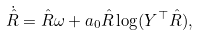Convert formula to latex. <formula><loc_0><loc_0><loc_500><loc_500>\dot { \hat { R } } & = \hat { R } \omega + a _ { 0 } \hat { R } \log ( Y ^ { \top } \hat { R } ) ,</formula> 